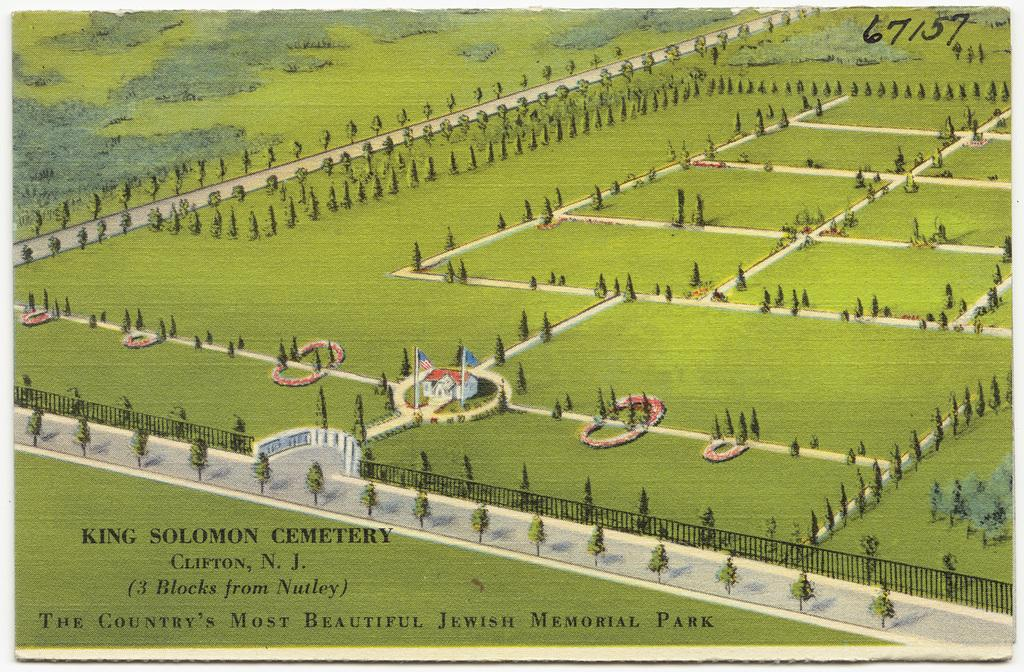What type of structure is visible in the image? There is a house in the image. What decorative elements can be seen in the image? There are flags in the image. What type of vegetation is present in the image? There are trees and grass in the image. What architectural feature is present in the image? There is a fence in the image. Is there any text or writing in the image? Yes, there is writing on the picture. How many snakes are slithering on the grass in the image? There are no snakes present in the image; it only features a house, flags, trees, grass, a fence, and writing. 